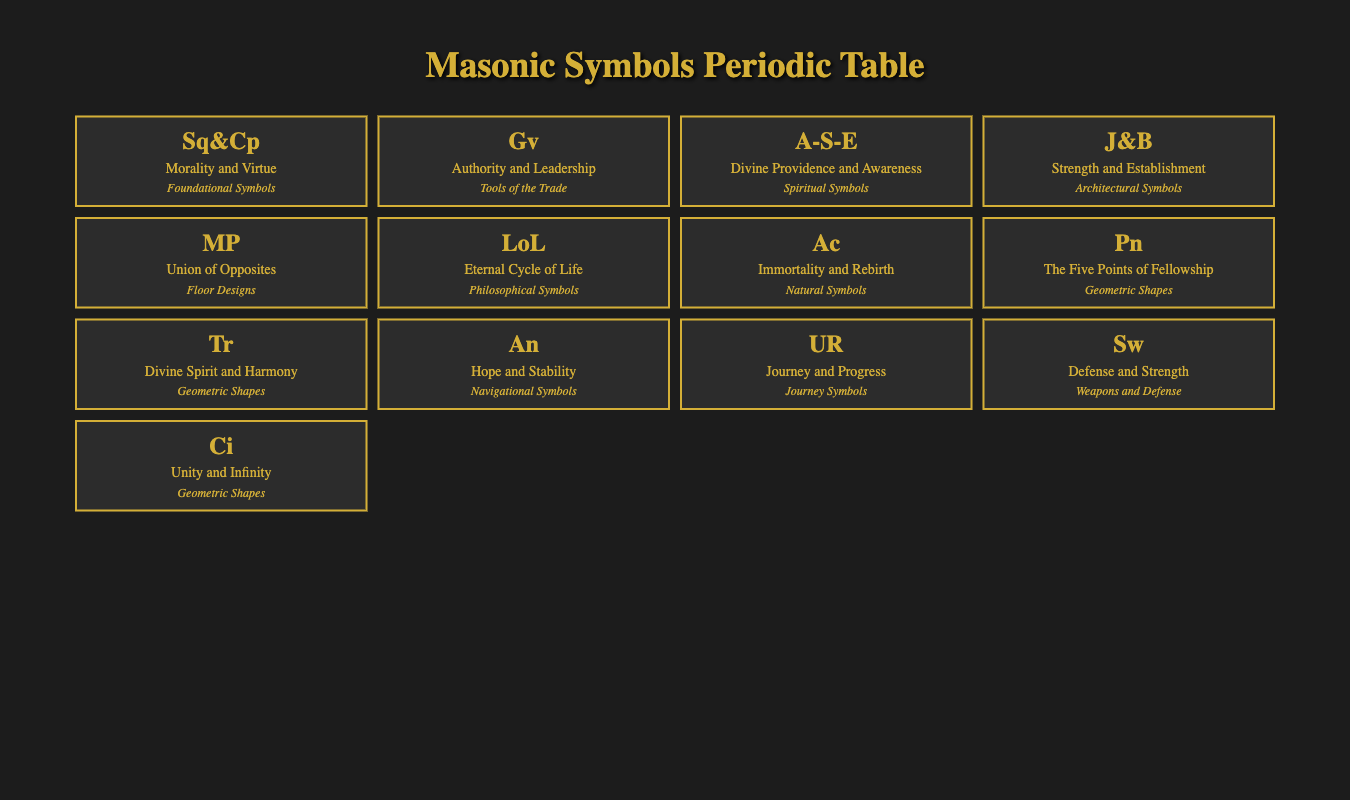What is the meaning of the "Square and Compasses" symbol? The meaning of the "Square and Compasses" symbol, as noted in the table, is "Morality and Virtue." This can be directly retrieved from the corresponding row in the table.
Answer: Morality and Virtue How many symbols are categorized as "Geometric Shapes"? By counting the symbols listed under the "Geometric Shapes" category, there are four: "Pentagram," "Triangle," "Circle." Thus, the total is 4.
Answer: 4 Is the "Anchor" symbol associated with hope? Yes, the "Anchor" symbol's meaning according to the table is "Hope and Stability," confirming its association with hope.
Answer: Yes What are the meanings of symbols in the "Natural Symbols" category? The only symbol listed in the "Natural Symbols" category is "Acacia," which means "Immortality and Rebirth." Since there's only one symbol in that category, the answer is straightforward.
Answer: Immortality and Rebirth Which symbol represents "Divine Spirit and Harmony," and what is its historical significance? The symbol representing "Divine Spirit and Harmony" is the "Triangle." Its historical significance, according to the table, is that it symbolizes the Trinity. This information can be extracted by locating the Triangle in the table and reading its associated meaning and historical significance.
Answer: Triangle; Symbolizes the Trinity Which symbol in the table is linked to the concept of "Eternal Cycle of Life"? The "Life of the Lodge" symbol represents the "Eternal Cycle of Life." This connection is explicitly stated in the table under the corresponding row.
Answer: Life of the Lodge What does the "Sword" symbol signify, and what is its historical context? The "Sword" symbolizes "Defense and Strength," and its historical significance deals with "Symbolizing Justice and Valor." This information can be gathered by examining the respective row for the "Sword" symbol in the table.
Answer: Defense and Strength; Symbolizing Justice and Valor What is the combined meaning of the "Pillars (Jachin and Boaz)" and "Mosaic Pavement"? The "Pillars (Jachin and Boaz)" represent "Strength and Establishment," while the "Mosaic Pavement" symbolizes the "Union of Opposites." To answer the question accurately, both meanings have to be summed up, resulting in "Strength and Establishment" + "Union of Opposites."
Answer: Strength and Establishment; Union of Opposites 